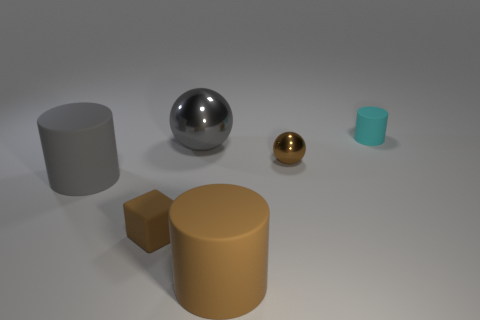Is there anything else that is the same shape as the small brown rubber thing?
Make the answer very short. No. What is the shape of the cyan rubber thing?
Keep it short and to the point. Cylinder. What color is the thing that is both right of the big gray metallic thing and in front of the gray matte object?
Keep it short and to the point. Brown. The metal object that is the same size as the gray rubber object is what shape?
Offer a terse response. Sphere. Are there any red things that have the same shape as the big brown matte thing?
Give a very brief answer. No. Is the material of the small cyan cylinder the same as the ball in front of the big ball?
Your response must be concise. No. There is a small rubber thing to the right of the large gray object that is right of the tiny object that is to the left of the brown cylinder; what color is it?
Your response must be concise. Cyan. What material is the cylinder that is the same size as the rubber cube?
Your answer should be compact. Rubber. What number of gray cylinders are the same material as the small sphere?
Provide a short and direct response. 0. Does the brown rubber object left of the gray metal object have the same size as the rubber thing left of the matte block?
Ensure brevity in your answer.  No. 